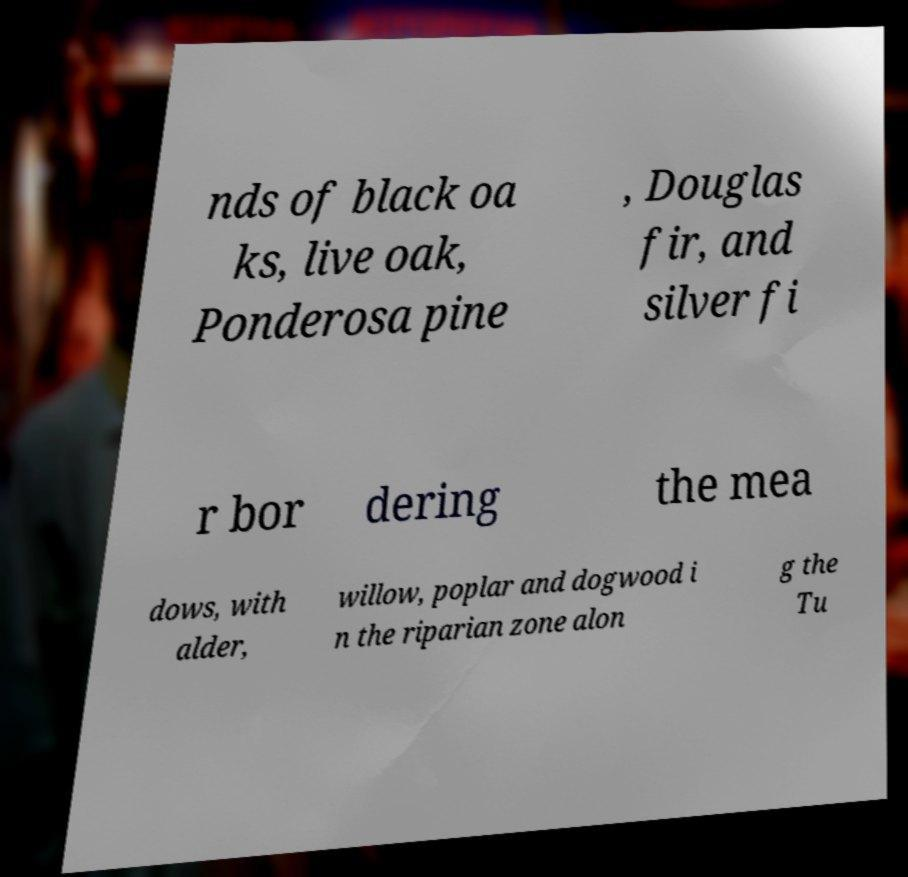Please read and relay the text visible in this image. What does it say? nds of black oa ks, live oak, Ponderosa pine , Douglas fir, and silver fi r bor dering the mea dows, with alder, willow, poplar and dogwood i n the riparian zone alon g the Tu 